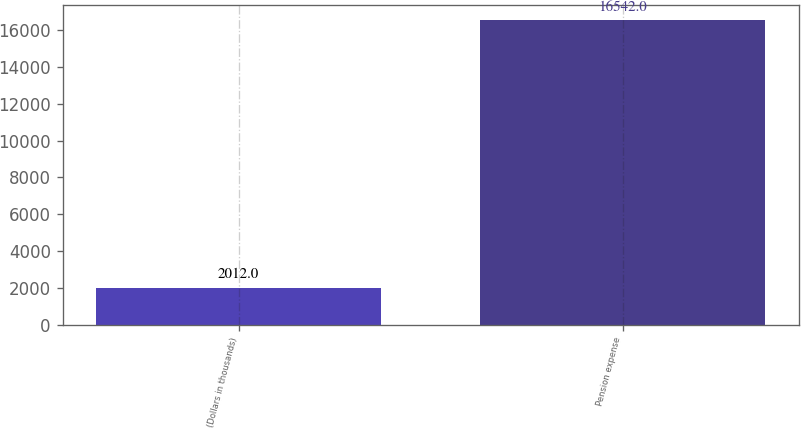Convert chart. <chart><loc_0><loc_0><loc_500><loc_500><bar_chart><fcel>(Dollars in thousands)<fcel>Pension expense<nl><fcel>2012<fcel>16542<nl></chart> 